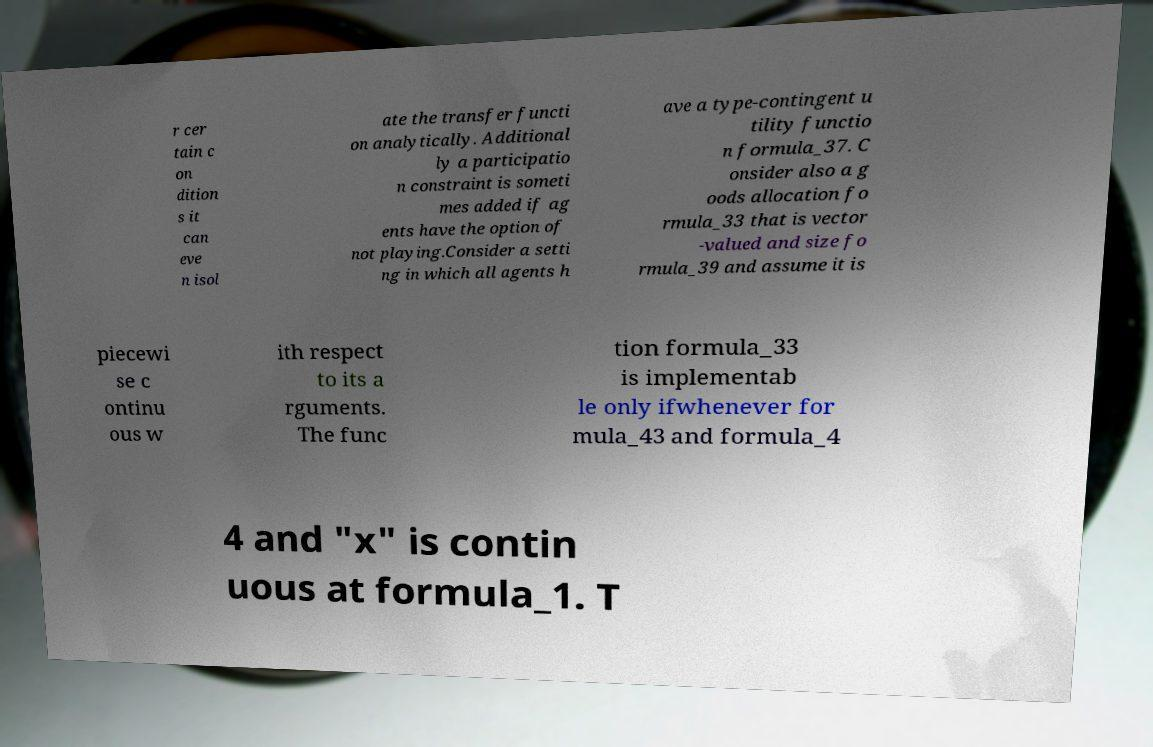Could you extract and type out the text from this image? r cer tain c on dition s it can eve n isol ate the transfer functi on analytically. Additional ly a participatio n constraint is someti mes added if ag ents have the option of not playing.Consider a setti ng in which all agents h ave a type-contingent u tility functio n formula_37. C onsider also a g oods allocation fo rmula_33 that is vector -valued and size fo rmula_39 and assume it is piecewi se c ontinu ous w ith respect to its a rguments. The func tion formula_33 is implementab le only ifwhenever for mula_43 and formula_4 4 and "x" is contin uous at formula_1. T 